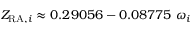<formula> <loc_0><loc_0><loc_500><loc_500>Z _ { { R A } , i } \approx 0 . 2 9 0 5 6 - 0 . 0 8 7 7 5 \ \omega _ { i }</formula> 